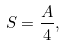<formula> <loc_0><loc_0><loc_500><loc_500>S = \frac { A } { 4 } ,</formula> 